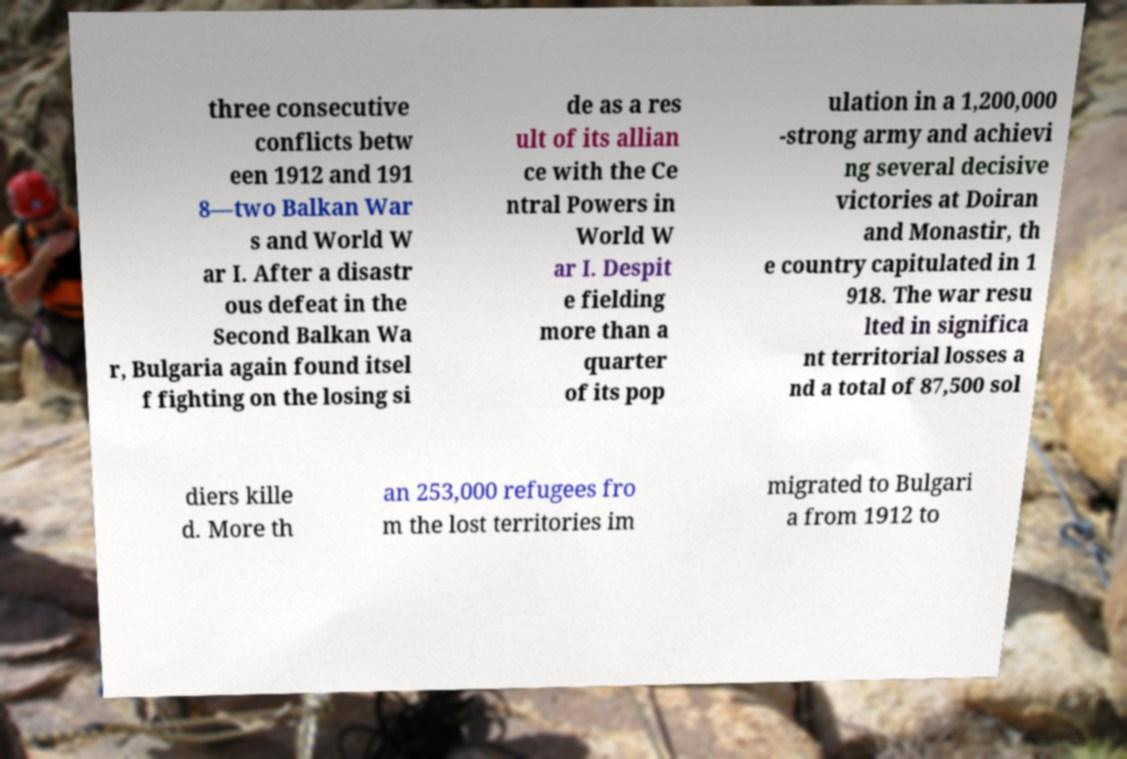Please read and relay the text visible in this image. What does it say? three consecutive conflicts betw een 1912 and 191 8—two Balkan War s and World W ar I. After a disastr ous defeat in the Second Balkan Wa r, Bulgaria again found itsel f fighting on the losing si de as a res ult of its allian ce with the Ce ntral Powers in World W ar I. Despit e fielding more than a quarter of its pop ulation in a 1,200,000 -strong army and achievi ng several decisive victories at Doiran and Monastir, th e country capitulated in 1 918. The war resu lted in significa nt territorial losses a nd a total of 87,500 sol diers kille d. More th an 253,000 refugees fro m the lost territories im migrated to Bulgari a from 1912 to 